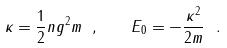<formula> <loc_0><loc_0><loc_500><loc_500>\kappa = \frac { 1 } { 2 } n g ^ { 2 } m \ , \quad E _ { 0 } = - \frac { \kappa ^ { 2 } } { 2 m } \ .</formula> 